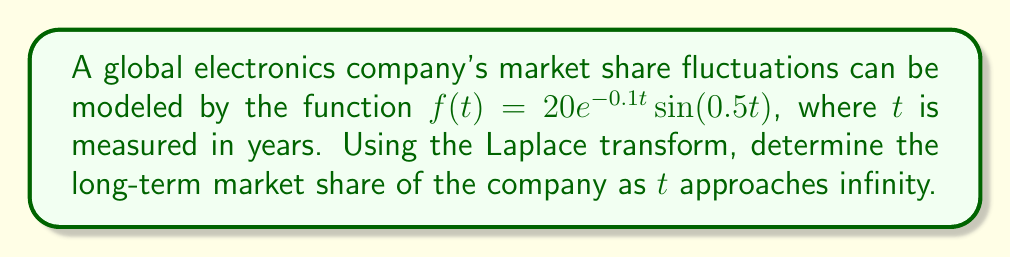Solve this math problem. To solve this problem, we'll follow these steps:

1) First, recall the Laplace transform of $f(t) = e^{at}\sin(bt)$:

   $$\mathcal{L}\{e^{at}\sin(bt)\} = \frac{b}{(s-a)^2 + b^2}$$

2) In our case, $a = -0.1$ and $b = 0.5$. We also have a constant factor of 20. So, the Laplace transform of our function is:

   $$F(s) = 20 \cdot \frac{0.5}{(s+0.1)^2 + 0.5^2}$$

3) To find the long-term behavior, we can use the Final Value Theorem. This theorem states that for a function $f(t)$ with Laplace transform $F(s)$:

   $$\lim_{t \to \infty} f(t) = \lim_{s \to 0} sF(s)$$

   provided these limits exist.

4) Let's apply this theorem:

   $$\lim_{t \to \infty} f(t) = \lim_{s \to 0} s \cdot 20 \cdot \frac{0.5}{(s+0.1)^2 + 0.5^2}$$

5) Simplify:

   $$= 20 \cdot 0.5 \cdot \lim_{s \to 0} \frac{s}{(s+0.1)^2 + 0.25}$$

6) As $s$ approaches 0, the denominator approaches $0.1^2 + 0.25 = 0.26$, while the numerator approaches 0:

   $$= 20 \cdot 0.5 \cdot \frac{0}{0.26} = 0$$

Therefore, the long-term market share of the company approaches 0 as time goes to infinity.
Answer: The long-term market share of the company as $t$ approaches infinity is 0. 